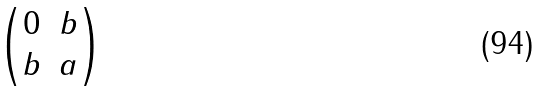<formula> <loc_0><loc_0><loc_500><loc_500>\begin{pmatrix} 0 & b \\ b & a \end{pmatrix}</formula> 